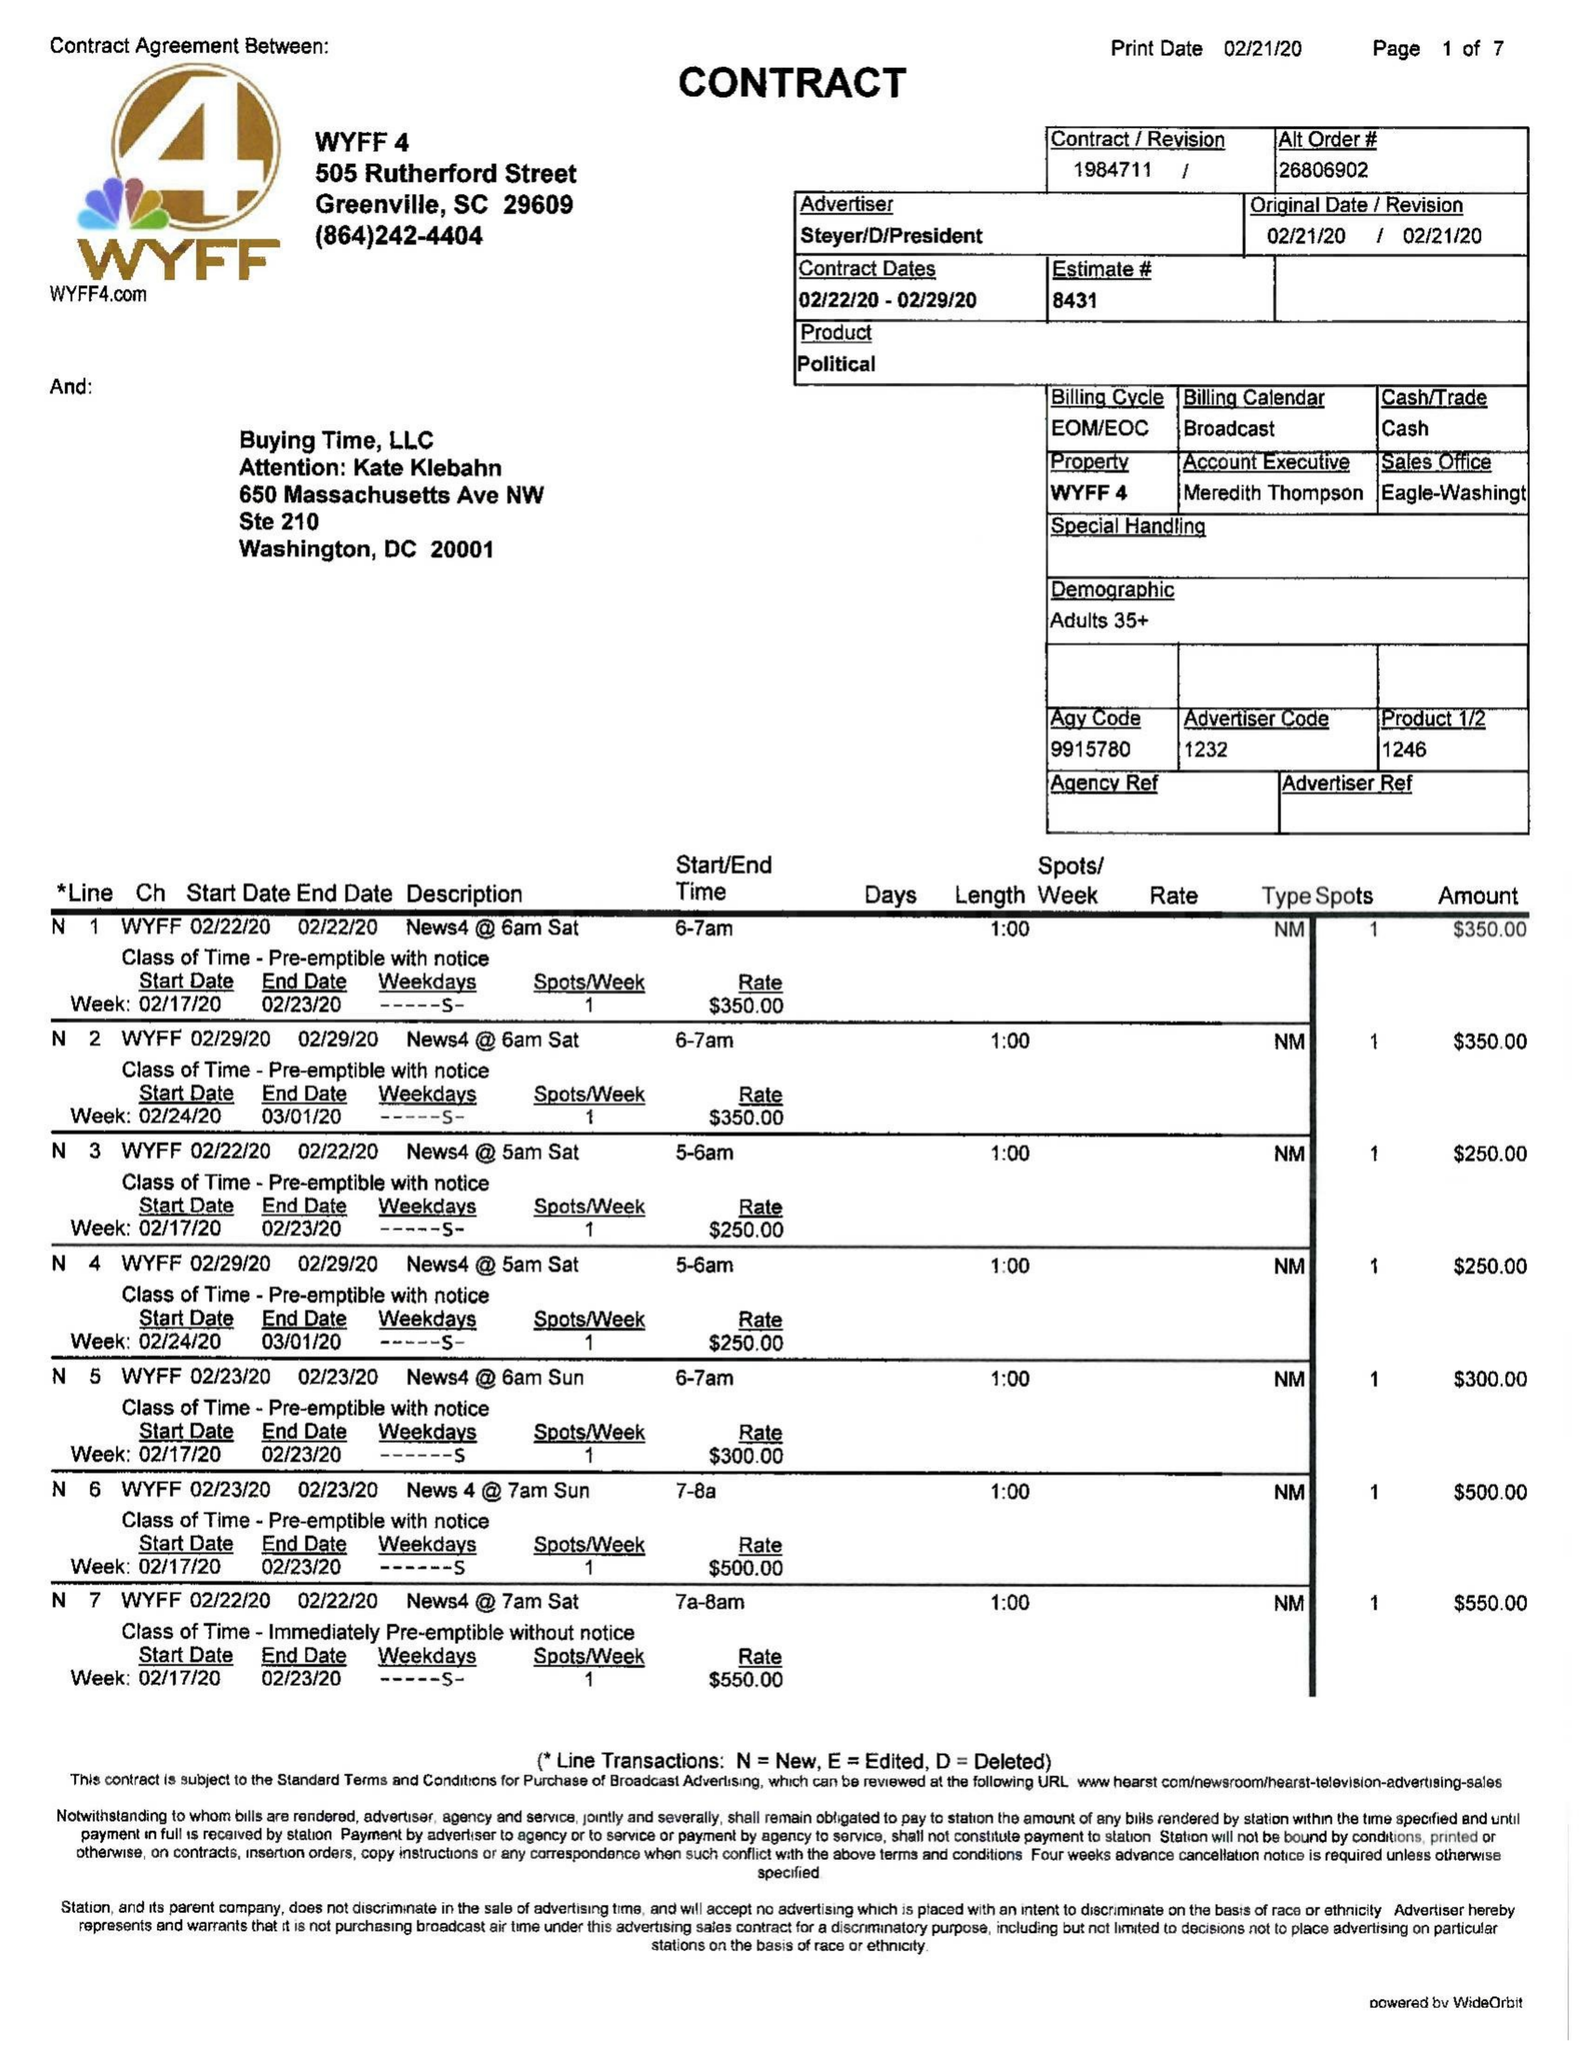What is the value for the advertiser?
Answer the question using a single word or phrase. STEYER/D/PRESIDENT 